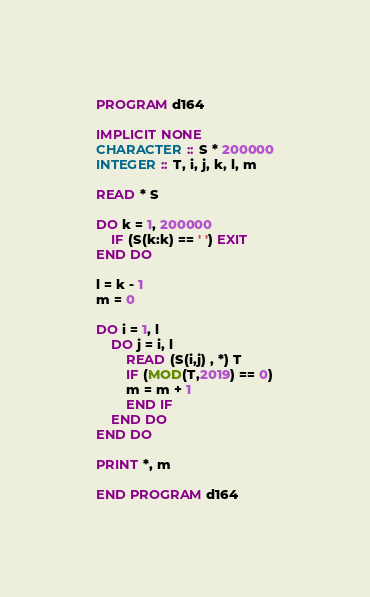<code> <loc_0><loc_0><loc_500><loc_500><_FORTRAN_>PROGRAM d164

IMPLICIT NONE
CHARACTER :: S * 200000
INTEGER :: T, i, j, k, l, m

READ * S

DO k = 1, 200000
	IF (S(k:k) == ' ') EXIT
END DO

l = k - 1
m = 0

DO i = 1, l
	DO j = i, l
    	READ (S(i,j) , *) T
        IF (MOD(T,2019) == 0)
        m = m + 1
        END IF
    END DO
END DO

PRINT *, m

END PROGRAM d164</code> 